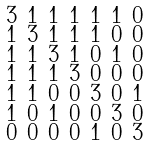Convert formula to latex. <formula><loc_0><loc_0><loc_500><loc_500>\begin{smallmatrix} 3 & 1 & 1 & 1 & 1 & 1 & 0 \\ 1 & 3 & 1 & 1 & 1 & 0 & 0 \\ 1 & 1 & 3 & 1 & 0 & 1 & 0 \\ 1 & 1 & 1 & 3 & 0 & 0 & 0 \\ 1 & 1 & 0 & 0 & 3 & 0 & 1 \\ 1 & 0 & 1 & 0 & 0 & 3 & 0 \\ 0 & 0 & 0 & 0 & 1 & 0 & 3 \end{smallmatrix}</formula> 